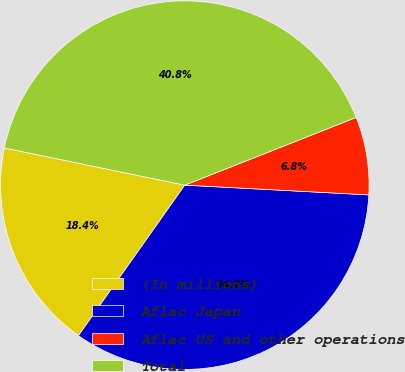Convert chart. <chart><loc_0><loc_0><loc_500><loc_500><pie_chart><fcel>(In millions)<fcel>Aflac Japan<fcel>Aflac US and other operations<fcel>Total<nl><fcel>18.44%<fcel>33.95%<fcel>6.83%<fcel>40.78%<nl></chart> 